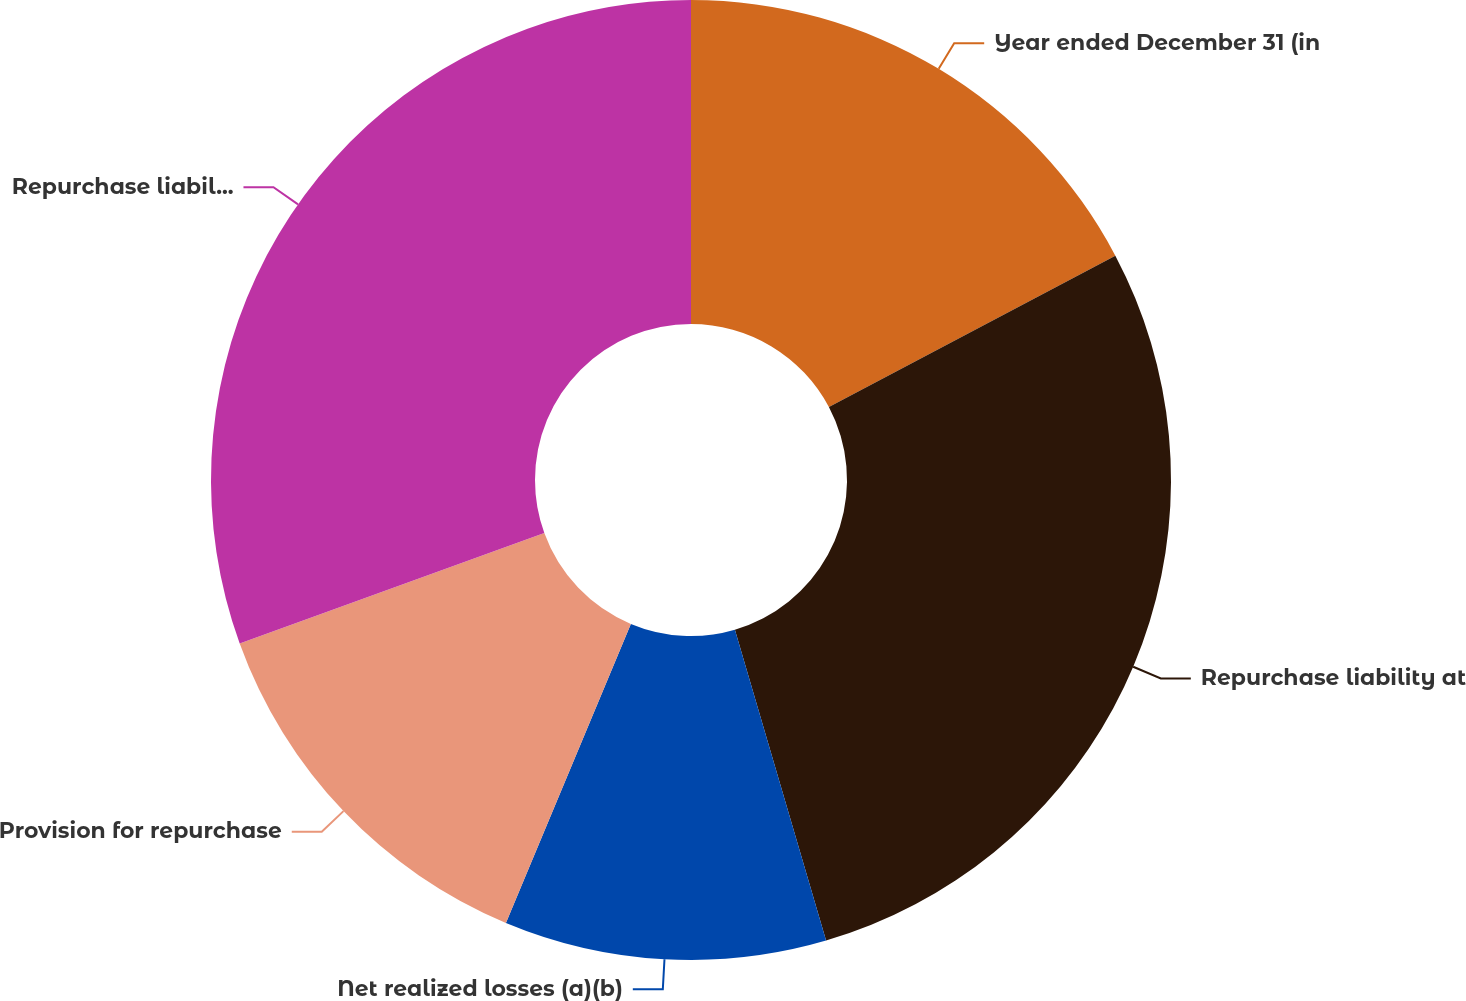Convert chart. <chart><loc_0><loc_0><loc_500><loc_500><pie_chart><fcel>Year ended December 31 (in<fcel>Repurchase liability at<fcel>Net realized losses (a)(b)<fcel>Provision for repurchase<fcel>Repurchase liability at end of<nl><fcel>17.26%<fcel>28.2%<fcel>10.84%<fcel>13.17%<fcel>30.53%<nl></chart> 